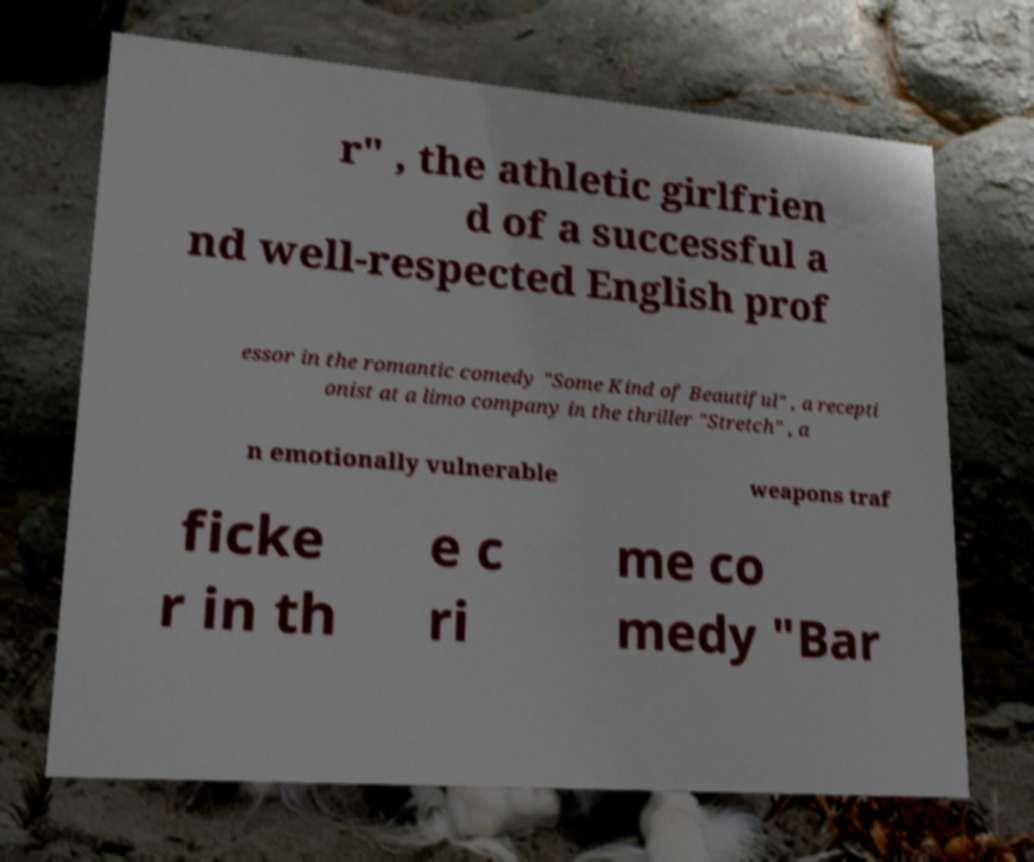Please read and relay the text visible in this image. What does it say? r" , the athletic girlfrien d of a successful a nd well-respected English prof essor in the romantic comedy "Some Kind of Beautiful" , a recepti onist at a limo company in the thriller "Stretch" , a n emotionally vulnerable weapons traf ficke r in th e c ri me co medy "Bar 